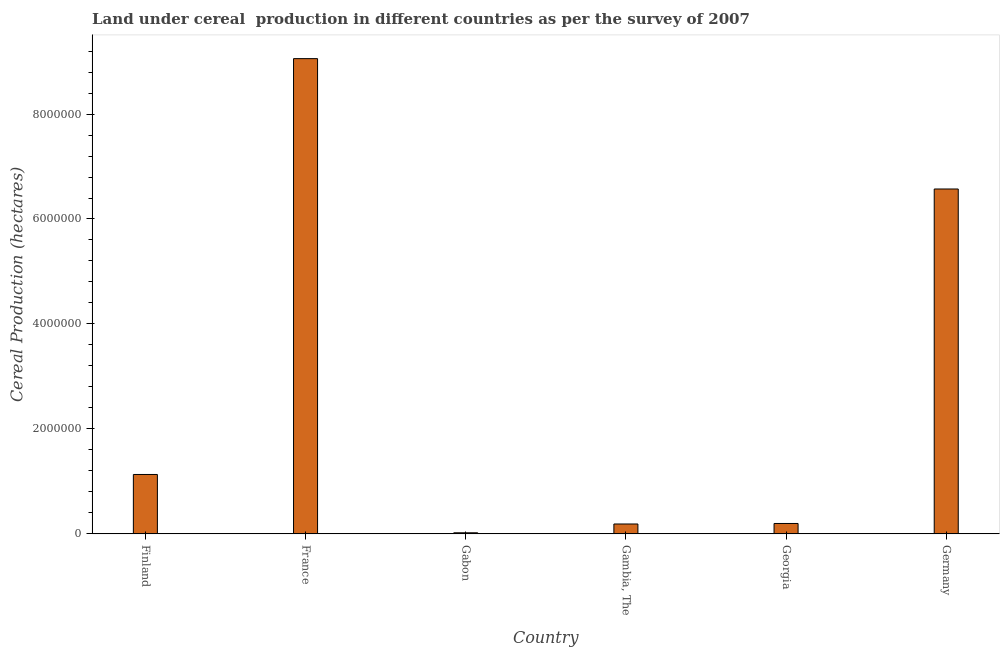Does the graph contain any zero values?
Give a very brief answer. No. Does the graph contain grids?
Your answer should be very brief. No. What is the title of the graph?
Make the answer very short. Land under cereal  production in different countries as per the survey of 2007. What is the label or title of the X-axis?
Offer a very short reply. Country. What is the label or title of the Y-axis?
Provide a succinct answer. Cereal Production (hectares). What is the land under cereal production in Gabon?
Keep it short and to the point. 2.05e+04. Across all countries, what is the maximum land under cereal production?
Keep it short and to the point. 9.06e+06. Across all countries, what is the minimum land under cereal production?
Keep it short and to the point. 2.05e+04. In which country was the land under cereal production maximum?
Your answer should be compact. France. In which country was the land under cereal production minimum?
Ensure brevity in your answer.  Gabon. What is the sum of the land under cereal production?
Keep it short and to the point. 1.72e+07. What is the difference between the land under cereal production in Gambia, The and Georgia?
Provide a succinct answer. -9920. What is the average land under cereal production per country?
Your answer should be very brief. 2.86e+06. What is the median land under cereal production?
Make the answer very short. 6.65e+05. What is the ratio of the land under cereal production in Gabon to that in Gambia, The?
Your answer should be compact. 0.11. What is the difference between the highest and the second highest land under cereal production?
Keep it short and to the point. 2.48e+06. Is the sum of the land under cereal production in France and Gabon greater than the maximum land under cereal production across all countries?
Provide a succinct answer. Yes. What is the difference between the highest and the lowest land under cereal production?
Provide a succinct answer. 9.04e+06. How many countries are there in the graph?
Offer a very short reply. 6. What is the difference between two consecutive major ticks on the Y-axis?
Offer a very short reply. 2.00e+06. What is the Cereal Production (hectares) of Finland?
Ensure brevity in your answer.  1.13e+06. What is the Cereal Production (hectares) in France?
Your answer should be compact. 9.06e+06. What is the Cereal Production (hectares) of Gabon?
Make the answer very short. 2.05e+04. What is the Cereal Production (hectares) of Gambia, The?
Offer a terse response. 1.88e+05. What is the Cereal Production (hectares) of Georgia?
Your answer should be very brief. 1.98e+05. What is the Cereal Production (hectares) in Germany?
Your response must be concise. 6.57e+06. What is the difference between the Cereal Production (hectares) in Finland and France?
Offer a very short reply. -7.92e+06. What is the difference between the Cereal Production (hectares) in Finland and Gabon?
Your answer should be very brief. 1.11e+06. What is the difference between the Cereal Production (hectares) in Finland and Gambia, The?
Keep it short and to the point. 9.43e+05. What is the difference between the Cereal Production (hectares) in Finland and Georgia?
Offer a terse response. 9.33e+05. What is the difference between the Cereal Production (hectares) in Finland and Germany?
Offer a terse response. -5.44e+06. What is the difference between the Cereal Production (hectares) in France and Gabon?
Offer a terse response. 9.04e+06. What is the difference between the Cereal Production (hectares) in France and Gambia, The?
Provide a short and direct response. 8.87e+06. What is the difference between the Cereal Production (hectares) in France and Georgia?
Offer a terse response. 8.86e+06. What is the difference between the Cereal Production (hectares) in France and Germany?
Your answer should be very brief. 2.48e+06. What is the difference between the Cereal Production (hectares) in Gabon and Gambia, The?
Provide a short and direct response. -1.68e+05. What is the difference between the Cereal Production (hectares) in Gabon and Georgia?
Your answer should be very brief. -1.78e+05. What is the difference between the Cereal Production (hectares) in Gabon and Germany?
Provide a short and direct response. -6.55e+06. What is the difference between the Cereal Production (hectares) in Gambia, The and Georgia?
Offer a very short reply. -9920. What is the difference between the Cereal Production (hectares) in Gambia, The and Germany?
Give a very brief answer. -6.38e+06. What is the difference between the Cereal Production (hectares) in Georgia and Germany?
Offer a terse response. -6.37e+06. What is the ratio of the Cereal Production (hectares) in Finland to that in Gabon?
Make the answer very short. 55.28. What is the ratio of the Cereal Production (hectares) in Finland to that in Gambia, The?
Keep it short and to the point. 6.01. What is the ratio of the Cereal Production (hectares) in Finland to that in Georgia?
Keep it short and to the point. 5.71. What is the ratio of the Cereal Production (hectares) in Finland to that in Germany?
Provide a short and direct response. 0.17. What is the ratio of the Cereal Production (hectares) in France to that in Gabon?
Your answer should be very brief. 442.39. What is the ratio of the Cereal Production (hectares) in France to that in Gambia, The?
Make the answer very short. 48.14. What is the ratio of the Cereal Production (hectares) in France to that in Georgia?
Make the answer very short. 45.73. What is the ratio of the Cereal Production (hectares) in France to that in Germany?
Your answer should be compact. 1.38. What is the ratio of the Cereal Production (hectares) in Gabon to that in Gambia, The?
Give a very brief answer. 0.11. What is the ratio of the Cereal Production (hectares) in Gabon to that in Georgia?
Offer a very short reply. 0.1. What is the ratio of the Cereal Production (hectares) in Gabon to that in Germany?
Keep it short and to the point. 0. What is the ratio of the Cereal Production (hectares) in Gambia, The to that in Germany?
Keep it short and to the point. 0.03. 